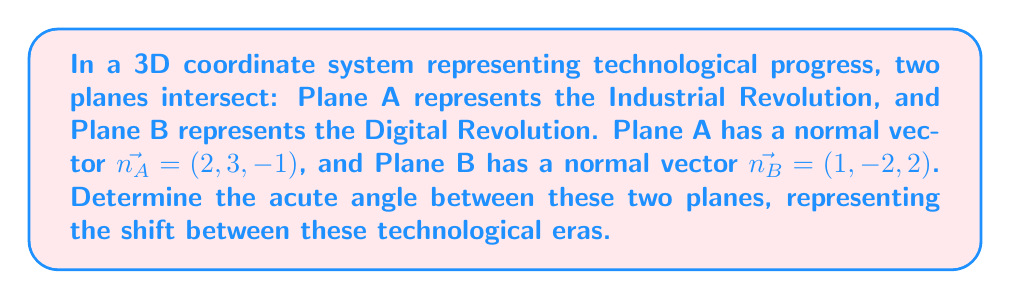What is the answer to this math problem? To find the angle between two intersecting planes, we can use the dot product of their normal vectors. The formula for the angle $\theta$ between two planes with normal vectors $\vec{n_1}$ and $\vec{n_2}$ is:

$$\cos \theta = \frac{|\vec{n_1} \cdot \vec{n_2}|}{|\vec{n_1}| |\vec{n_2}|}$$

Step 1: Calculate the dot product of $\vec{n_A}$ and $\vec{n_B}$:
$$\vec{n_A} \cdot \vec{n_B} = (2)(1) + (3)(-2) + (-1)(2) = 2 - 6 - 2 = -6$$

Step 2: Calculate the magnitudes of $\vec{n_A}$ and $\vec{n_B}$:
$$|\vec{n_A}| = \sqrt{2^2 + 3^2 + (-1)^2} = \sqrt{4 + 9 + 1} = \sqrt{14}$$
$$|\vec{n_B}| = \sqrt{1^2 + (-2)^2 + 2^2} = \sqrt{1 + 4 + 4} = 3$$

Step 3: Apply the formula:
$$\cos \theta = \frac{|-6|}{\sqrt{14} \cdot 3} = \frac{6}{\sqrt{14} \cdot 3}$$

Step 4: Take the inverse cosine (arccos) of both sides:
$$\theta = \arccos\left(\frac{6}{\sqrt{14} \cdot 3}\right)$$

Step 5: Calculate the result:
$$\theta \approx 1.2490 \text{ radians} \approx 71.57°$$

This angle represents the acute angle between the two planes.
Answer: $71.57°$ 